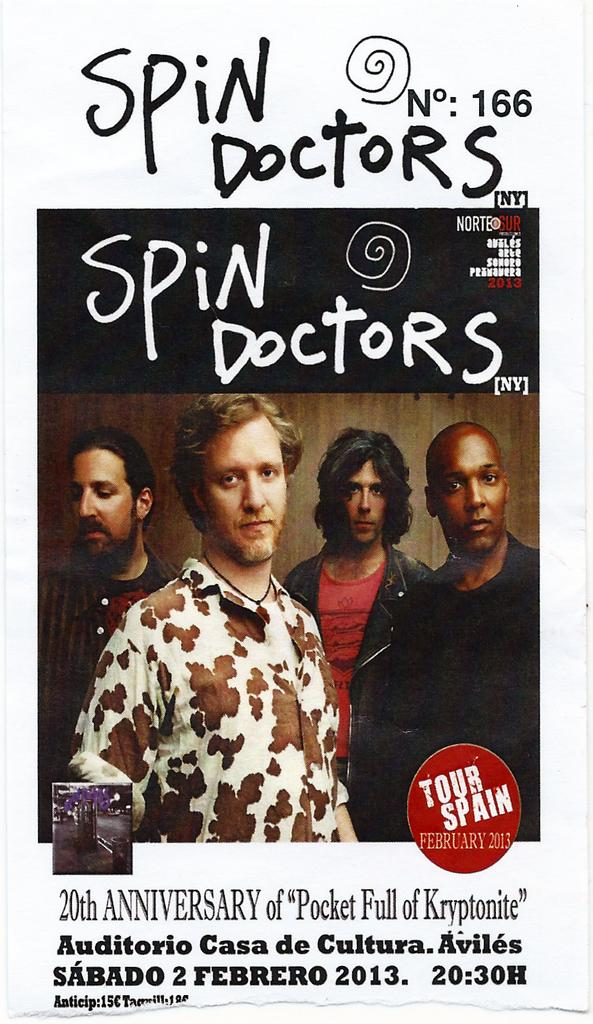Provide a one-sentence caption for the provided image. a poster for the Spin Doctors 20th Anniversary. 